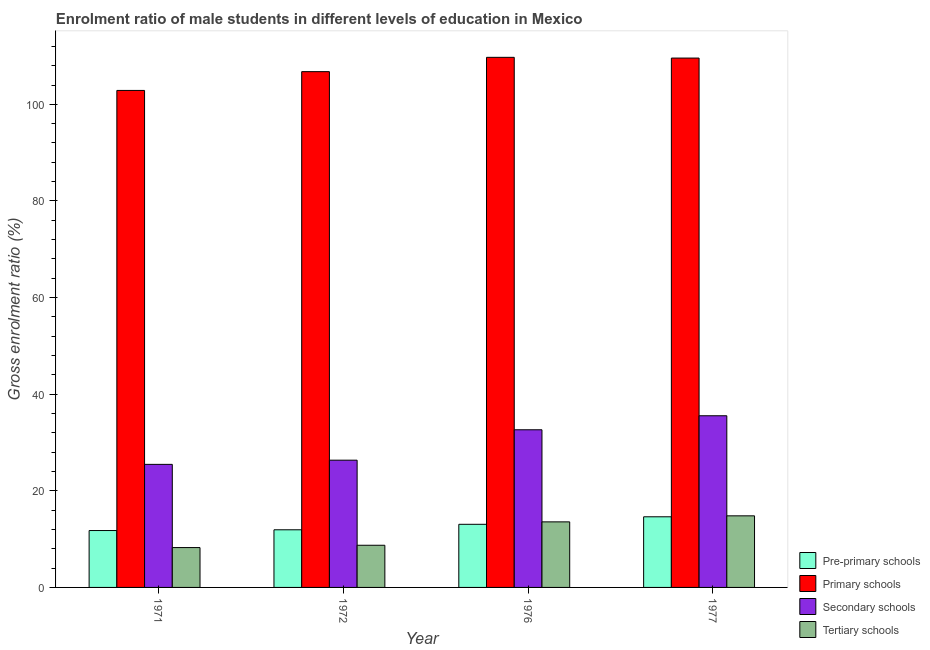Are the number of bars per tick equal to the number of legend labels?
Give a very brief answer. Yes. Are the number of bars on each tick of the X-axis equal?
Your answer should be compact. Yes. How many bars are there on the 3rd tick from the right?
Offer a terse response. 4. What is the label of the 2nd group of bars from the left?
Offer a terse response. 1972. In how many cases, is the number of bars for a given year not equal to the number of legend labels?
Your answer should be very brief. 0. What is the gross enrolment ratio(female) in secondary schools in 1977?
Give a very brief answer. 35.54. Across all years, what is the maximum gross enrolment ratio(female) in primary schools?
Your answer should be compact. 109.73. Across all years, what is the minimum gross enrolment ratio(female) in pre-primary schools?
Make the answer very short. 11.78. In which year was the gross enrolment ratio(female) in primary schools maximum?
Your response must be concise. 1976. What is the total gross enrolment ratio(female) in primary schools in the graph?
Your answer should be very brief. 428.96. What is the difference between the gross enrolment ratio(female) in tertiary schools in 1972 and that in 1977?
Keep it short and to the point. -6.09. What is the difference between the gross enrolment ratio(female) in pre-primary schools in 1971 and the gross enrolment ratio(female) in tertiary schools in 1976?
Give a very brief answer. -1.29. What is the average gross enrolment ratio(female) in secondary schools per year?
Offer a very short reply. 30. What is the ratio of the gross enrolment ratio(female) in primary schools in 1971 to that in 1972?
Provide a short and direct response. 0.96. What is the difference between the highest and the second highest gross enrolment ratio(female) in pre-primary schools?
Keep it short and to the point. 1.56. What is the difference between the highest and the lowest gross enrolment ratio(female) in secondary schools?
Keep it short and to the point. 10.06. What does the 1st bar from the left in 1977 represents?
Make the answer very short. Pre-primary schools. What does the 2nd bar from the right in 1971 represents?
Make the answer very short. Secondary schools. Is it the case that in every year, the sum of the gross enrolment ratio(female) in pre-primary schools and gross enrolment ratio(female) in primary schools is greater than the gross enrolment ratio(female) in secondary schools?
Your response must be concise. Yes. What is the difference between two consecutive major ticks on the Y-axis?
Your answer should be compact. 20. Does the graph contain grids?
Make the answer very short. No. How many legend labels are there?
Provide a short and direct response. 4. How are the legend labels stacked?
Offer a terse response. Vertical. What is the title of the graph?
Give a very brief answer. Enrolment ratio of male students in different levels of education in Mexico. Does "Secondary vocational education" appear as one of the legend labels in the graph?
Give a very brief answer. No. What is the label or title of the Y-axis?
Make the answer very short. Gross enrolment ratio (%). What is the Gross enrolment ratio (%) of Pre-primary schools in 1971?
Keep it short and to the point. 11.78. What is the Gross enrolment ratio (%) of Primary schools in 1971?
Ensure brevity in your answer.  102.88. What is the Gross enrolment ratio (%) in Secondary schools in 1971?
Your answer should be compact. 25.47. What is the Gross enrolment ratio (%) in Tertiary schools in 1971?
Your response must be concise. 8.25. What is the Gross enrolment ratio (%) in Pre-primary schools in 1972?
Provide a succinct answer. 11.93. What is the Gross enrolment ratio (%) in Primary schools in 1972?
Your answer should be compact. 106.77. What is the Gross enrolment ratio (%) in Secondary schools in 1972?
Your response must be concise. 26.34. What is the Gross enrolment ratio (%) of Tertiary schools in 1972?
Your answer should be very brief. 8.73. What is the Gross enrolment ratio (%) of Pre-primary schools in 1976?
Your answer should be compact. 13.06. What is the Gross enrolment ratio (%) of Primary schools in 1976?
Ensure brevity in your answer.  109.73. What is the Gross enrolment ratio (%) of Secondary schools in 1976?
Offer a very short reply. 32.63. What is the Gross enrolment ratio (%) in Tertiary schools in 1976?
Keep it short and to the point. 13.57. What is the Gross enrolment ratio (%) in Pre-primary schools in 1977?
Keep it short and to the point. 14.62. What is the Gross enrolment ratio (%) of Primary schools in 1977?
Offer a terse response. 109.58. What is the Gross enrolment ratio (%) in Secondary schools in 1977?
Provide a short and direct response. 35.54. What is the Gross enrolment ratio (%) of Tertiary schools in 1977?
Give a very brief answer. 14.82. Across all years, what is the maximum Gross enrolment ratio (%) in Pre-primary schools?
Ensure brevity in your answer.  14.62. Across all years, what is the maximum Gross enrolment ratio (%) of Primary schools?
Make the answer very short. 109.73. Across all years, what is the maximum Gross enrolment ratio (%) of Secondary schools?
Provide a short and direct response. 35.54. Across all years, what is the maximum Gross enrolment ratio (%) in Tertiary schools?
Your answer should be very brief. 14.82. Across all years, what is the minimum Gross enrolment ratio (%) of Pre-primary schools?
Provide a succinct answer. 11.78. Across all years, what is the minimum Gross enrolment ratio (%) in Primary schools?
Provide a succinct answer. 102.88. Across all years, what is the minimum Gross enrolment ratio (%) in Secondary schools?
Ensure brevity in your answer.  25.47. Across all years, what is the minimum Gross enrolment ratio (%) in Tertiary schools?
Provide a short and direct response. 8.25. What is the total Gross enrolment ratio (%) in Pre-primary schools in the graph?
Offer a terse response. 51.39. What is the total Gross enrolment ratio (%) of Primary schools in the graph?
Your response must be concise. 428.96. What is the total Gross enrolment ratio (%) in Secondary schools in the graph?
Offer a terse response. 119.99. What is the total Gross enrolment ratio (%) in Tertiary schools in the graph?
Offer a terse response. 45.37. What is the difference between the Gross enrolment ratio (%) of Pre-primary schools in 1971 and that in 1972?
Offer a very short reply. -0.15. What is the difference between the Gross enrolment ratio (%) in Primary schools in 1971 and that in 1972?
Make the answer very short. -3.89. What is the difference between the Gross enrolment ratio (%) in Secondary schools in 1971 and that in 1972?
Make the answer very short. -0.87. What is the difference between the Gross enrolment ratio (%) in Tertiary schools in 1971 and that in 1972?
Provide a succinct answer. -0.48. What is the difference between the Gross enrolment ratio (%) in Pre-primary schools in 1971 and that in 1976?
Provide a succinct answer. -1.29. What is the difference between the Gross enrolment ratio (%) of Primary schools in 1971 and that in 1976?
Provide a succinct answer. -6.85. What is the difference between the Gross enrolment ratio (%) of Secondary schools in 1971 and that in 1976?
Ensure brevity in your answer.  -7.16. What is the difference between the Gross enrolment ratio (%) of Tertiary schools in 1971 and that in 1976?
Offer a very short reply. -5.32. What is the difference between the Gross enrolment ratio (%) of Pre-primary schools in 1971 and that in 1977?
Offer a terse response. -2.84. What is the difference between the Gross enrolment ratio (%) in Primary schools in 1971 and that in 1977?
Offer a very short reply. -6.7. What is the difference between the Gross enrolment ratio (%) in Secondary schools in 1971 and that in 1977?
Make the answer very short. -10.06. What is the difference between the Gross enrolment ratio (%) of Tertiary schools in 1971 and that in 1977?
Your answer should be very brief. -6.57. What is the difference between the Gross enrolment ratio (%) in Pre-primary schools in 1972 and that in 1976?
Your response must be concise. -1.13. What is the difference between the Gross enrolment ratio (%) of Primary schools in 1972 and that in 1976?
Your answer should be compact. -2.96. What is the difference between the Gross enrolment ratio (%) in Secondary schools in 1972 and that in 1976?
Your answer should be compact. -6.29. What is the difference between the Gross enrolment ratio (%) of Tertiary schools in 1972 and that in 1976?
Make the answer very short. -4.84. What is the difference between the Gross enrolment ratio (%) in Pre-primary schools in 1972 and that in 1977?
Give a very brief answer. -2.69. What is the difference between the Gross enrolment ratio (%) of Primary schools in 1972 and that in 1977?
Provide a short and direct response. -2.81. What is the difference between the Gross enrolment ratio (%) of Secondary schools in 1972 and that in 1977?
Offer a terse response. -9.2. What is the difference between the Gross enrolment ratio (%) of Tertiary schools in 1972 and that in 1977?
Keep it short and to the point. -6.09. What is the difference between the Gross enrolment ratio (%) of Pre-primary schools in 1976 and that in 1977?
Provide a short and direct response. -1.56. What is the difference between the Gross enrolment ratio (%) of Primary schools in 1976 and that in 1977?
Your answer should be compact. 0.15. What is the difference between the Gross enrolment ratio (%) in Secondary schools in 1976 and that in 1977?
Provide a succinct answer. -2.9. What is the difference between the Gross enrolment ratio (%) of Tertiary schools in 1976 and that in 1977?
Offer a terse response. -1.25. What is the difference between the Gross enrolment ratio (%) in Pre-primary schools in 1971 and the Gross enrolment ratio (%) in Primary schools in 1972?
Provide a succinct answer. -94.99. What is the difference between the Gross enrolment ratio (%) of Pre-primary schools in 1971 and the Gross enrolment ratio (%) of Secondary schools in 1972?
Give a very brief answer. -14.56. What is the difference between the Gross enrolment ratio (%) in Pre-primary schools in 1971 and the Gross enrolment ratio (%) in Tertiary schools in 1972?
Your answer should be very brief. 3.05. What is the difference between the Gross enrolment ratio (%) in Primary schools in 1971 and the Gross enrolment ratio (%) in Secondary schools in 1972?
Your response must be concise. 76.54. What is the difference between the Gross enrolment ratio (%) in Primary schools in 1971 and the Gross enrolment ratio (%) in Tertiary schools in 1972?
Keep it short and to the point. 94.15. What is the difference between the Gross enrolment ratio (%) of Secondary schools in 1971 and the Gross enrolment ratio (%) of Tertiary schools in 1972?
Offer a terse response. 16.75. What is the difference between the Gross enrolment ratio (%) in Pre-primary schools in 1971 and the Gross enrolment ratio (%) in Primary schools in 1976?
Your response must be concise. -97.96. What is the difference between the Gross enrolment ratio (%) in Pre-primary schools in 1971 and the Gross enrolment ratio (%) in Secondary schools in 1976?
Keep it short and to the point. -20.86. What is the difference between the Gross enrolment ratio (%) in Pre-primary schools in 1971 and the Gross enrolment ratio (%) in Tertiary schools in 1976?
Provide a succinct answer. -1.79. What is the difference between the Gross enrolment ratio (%) of Primary schools in 1971 and the Gross enrolment ratio (%) of Secondary schools in 1976?
Ensure brevity in your answer.  70.25. What is the difference between the Gross enrolment ratio (%) of Primary schools in 1971 and the Gross enrolment ratio (%) of Tertiary schools in 1976?
Make the answer very short. 89.31. What is the difference between the Gross enrolment ratio (%) in Secondary schools in 1971 and the Gross enrolment ratio (%) in Tertiary schools in 1976?
Make the answer very short. 11.9. What is the difference between the Gross enrolment ratio (%) of Pre-primary schools in 1971 and the Gross enrolment ratio (%) of Primary schools in 1977?
Your response must be concise. -97.8. What is the difference between the Gross enrolment ratio (%) of Pre-primary schools in 1971 and the Gross enrolment ratio (%) of Secondary schools in 1977?
Offer a very short reply. -23.76. What is the difference between the Gross enrolment ratio (%) of Pre-primary schools in 1971 and the Gross enrolment ratio (%) of Tertiary schools in 1977?
Your answer should be very brief. -3.04. What is the difference between the Gross enrolment ratio (%) in Primary schools in 1971 and the Gross enrolment ratio (%) in Secondary schools in 1977?
Provide a succinct answer. 67.34. What is the difference between the Gross enrolment ratio (%) of Primary schools in 1971 and the Gross enrolment ratio (%) of Tertiary schools in 1977?
Make the answer very short. 88.06. What is the difference between the Gross enrolment ratio (%) in Secondary schools in 1971 and the Gross enrolment ratio (%) in Tertiary schools in 1977?
Provide a succinct answer. 10.65. What is the difference between the Gross enrolment ratio (%) of Pre-primary schools in 1972 and the Gross enrolment ratio (%) of Primary schools in 1976?
Your answer should be very brief. -97.8. What is the difference between the Gross enrolment ratio (%) in Pre-primary schools in 1972 and the Gross enrolment ratio (%) in Secondary schools in 1976?
Your response must be concise. -20.7. What is the difference between the Gross enrolment ratio (%) of Pre-primary schools in 1972 and the Gross enrolment ratio (%) of Tertiary schools in 1976?
Your response must be concise. -1.64. What is the difference between the Gross enrolment ratio (%) of Primary schools in 1972 and the Gross enrolment ratio (%) of Secondary schools in 1976?
Offer a terse response. 74.13. What is the difference between the Gross enrolment ratio (%) of Primary schools in 1972 and the Gross enrolment ratio (%) of Tertiary schools in 1976?
Your response must be concise. 93.2. What is the difference between the Gross enrolment ratio (%) in Secondary schools in 1972 and the Gross enrolment ratio (%) in Tertiary schools in 1976?
Provide a short and direct response. 12.77. What is the difference between the Gross enrolment ratio (%) in Pre-primary schools in 1972 and the Gross enrolment ratio (%) in Primary schools in 1977?
Your response must be concise. -97.65. What is the difference between the Gross enrolment ratio (%) in Pre-primary schools in 1972 and the Gross enrolment ratio (%) in Secondary schools in 1977?
Ensure brevity in your answer.  -23.61. What is the difference between the Gross enrolment ratio (%) of Pre-primary schools in 1972 and the Gross enrolment ratio (%) of Tertiary schools in 1977?
Offer a very short reply. -2.89. What is the difference between the Gross enrolment ratio (%) in Primary schools in 1972 and the Gross enrolment ratio (%) in Secondary schools in 1977?
Offer a terse response. 71.23. What is the difference between the Gross enrolment ratio (%) in Primary schools in 1972 and the Gross enrolment ratio (%) in Tertiary schools in 1977?
Provide a short and direct response. 91.95. What is the difference between the Gross enrolment ratio (%) of Secondary schools in 1972 and the Gross enrolment ratio (%) of Tertiary schools in 1977?
Offer a very short reply. 11.52. What is the difference between the Gross enrolment ratio (%) in Pre-primary schools in 1976 and the Gross enrolment ratio (%) in Primary schools in 1977?
Your response must be concise. -96.51. What is the difference between the Gross enrolment ratio (%) in Pre-primary schools in 1976 and the Gross enrolment ratio (%) in Secondary schools in 1977?
Give a very brief answer. -22.47. What is the difference between the Gross enrolment ratio (%) in Pre-primary schools in 1976 and the Gross enrolment ratio (%) in Tertiary schools in 1977?
Your answer should be compact. -1.75. What is the difference between the Gross enrolment ratio (%) of Primary schools in 1976 and the Gross enrolment ratio (%) of Secondary schools in 1977?
Offer a very short reply. 74.2. What is the difference between the Gross enrolment ratio (%) in Primary schools in 1976 and the Gross enrolment ratio (%) in Tertiary schools in 1977?
Provide a short and direct response. 94.91. What is the difference between the Gross enrolment ratio (%) in Secondary schools in 1976 and the Gross enrolment ratio (%) in Tertiary schools in 1977?
Provide a succinct answer. 17.82. What is the average Gross enrolment ratio (%) in Pre-primary schools per year?
Offer a terse response. 12.85. What is the average Gross enrolment ratio (%) of Primary schools per year?
Make the answer very short. 107.24. What is the average Gross enrolment ratio (%) in Secondary schools per year?
Keep it short and to the point. 30. What is the average Gross enrolment ratio (%) in Tertiary schools per year?
Your response must be concise. 11.34. In the year 1971, what is the difference between the Gross enrolment ratio (%) in Pre-primary schools and Gross enrolment ratio (%) in Primary schools?
Your answer should be compact. -91.1. In the year 1971, what is the difference between the Gross enrolment ratio (%) of Pre-primary schools and Gross enrolment ratio (%) of Secondary schools?
Make the answer very short. -13.7. In the year 1971, what is the difference between the Gross enrolment ratio (%) of Pre-primary schools and Gross enrolment ratio (%) of Tertiary schools?
Your response must be concise. 3.53. In the year 1971, what is the difference between the Gross enrolment ratio (%) in Primary schools and Gross enrolment ratio (%) in Secondary schools?
Offer a very short reply. 77.41. In the year 1971, what is the difference between the Gross enrolment ratio (%) of Primary schools and Gross enrolment ratio (%) of Tertiary schools?
Ensure brevity in your answer.  94.63. In the year 1971, what is the difference between the Gross enrolment ratio (%) in Secondary schools and Gross enrolment ratio (%) in Tertiary schools?
Your answer should be compact. 17.22. In the year 1972, what is the difference between the Gross enrolment ratio (%) in Pre-primary schools and Gross enrolment ratio (%) in Primary schools?
Your answer should be compact. -94.84. In the year 1972, what is the difference between the Gross enrolment ratio (%) in Pre-primary schools and Gross enrolment ratio (%) in Secondary schools?
Provide a short and direct response. -14.41. In the year 1972, what is the difference between the Gross enrolment ratio (%) of Pre-primary schools and Gross enrolment ratio (%) of Tertiary schools?
Give a very brief answer. 3.2. In the year 1972, what is the difference between the Gross enrolment ratio (%) of Primary schools and Gross enrolment ratio (%) of Secondary schools?
Offer a terse response. 80.43. In the year 1972, what is the difference between the Gross enrolment ratio (%) of Primary schools and Gross enrolment ratio (%) of Tertiary schools?
Your answer should be very brief. 98.04. In the year 1972, what is the difference between the Gross enrolment ratio (%) of Secondary schools and Gross enrolment ratio (%) of Tertiary schools?
Your answer should be very brief. 17.61. In the year 1976, what is the difference between the Gross enrolment ratio (%) in Pre-primary schools and Gross enrolment ratio (%) in Primary schools?
Provide a succinct answer. -96.67. In the year 1976, what is the difference between the Gross enrolment ratio (%) of Pre-primary schools and Gross enrolment ratio (%) of Secondary schools?
Keep it short and to the point. -19.57. In the year 1976, what is the difference between the Gross enrolment ratio (%) of Pre-primary schools and Gross enrolment ratio (%) of Tertiary schools?
Your response must be concise. -0.51. In the year 1976, what is the difference between the Gross enrolment ratio (%) in Primary schools and Gross enrolment ratio (%) in Secondary schools?
Offer a terse response. 77.1. In the year 1976, what is the difference between the Gross enrolment ratio (%) in Primary schools and Gross enrolment ratio (%) in Tertiary schools?
Provide a short and direct response. 96.16. In the year 1976, what is the difference between the Gross enrolment ratio (%) of Secondary schools and Gross enrolment ratio (%) of Tertiary schools?
Ensure brevity in your answer.  19.06. In the year 1977, what is the difference between the Gross enrolment ratio (%) of Pre-primary schools and Gross enrolment ratio (%) of Primary schools?
Keep it short and to the point. -94.96. In the year 1977, what is the difference between the Gross enrolment ratio (%) in Pre-primary schools and Gross enrolment ratio (%) in Secondary schools?
Offer a very short reply. -20.92. In the year 1977, what is the difference between the Gross enrolment ratio (%) in Pre-primary schools and Gross enrolment ratio (%) in Tertiary schools?
Give a very brief answer. -0.2. In the year 1977, what is the difference between the Gross enrolment ratio (%) of Primary schools and Gross enrolment ratio (%) of Secondary schools?
Offer a very short reply. 74.04. In the year 1977, what is the difference between the Gross enrolment ratio (%) of Primary schools and Gross enrolment ratio (%) of Tertiary schools?
Give a very brief answer. 94.76. In the year 1977, what is the difference between the Gross enrolment ratio (%) of Secondary schools and Gross enrolment ratio (%) of Tertiary schools?
Give a very brief answer. 20.72. What is the ratio of the Gross enrolment ratio (%) in Pre-primary schools in 1971 to that in 1972?
Make the answer very short. 0.99. What is the ratio of the Gross enrolment ratio (%) of Primary schools in 1971 to that in 1972?
Make the answer very short. 0.96. What is the ratio of the Gross enrolment ratio (%) of Tertiary schools in 1971 to that in 1972?
Ensure brevity in your answer.  0.95. What is the ratio of the Gross enrolment ratio (%) of Pre-primary schools in 1971 to that in 1976?
Your answer should be compact. 0.9. What is the ratio of the Gross enrolment ratio (%) of Primary schools in 1971 to that in 1976?
Make the answer very short. 0.94. What is the ratio of the Gross enrolment ratio (%) of Secondary schools in 1971 to that in 1976?
Give a very brief answer. 0.78. What is the ratio of the Gross enrolment ratio (%) of Tertiary schools in 1971 to that in 1976?
Your response must be concise. 0.61. What is the ratio of the Gross enrolment ratio (%) of Pre-primary schools in 1971 to that in 1977?
Ensure brevity in your answer.  0.81. What is the ratio of the Gross enrolment ratio (%) in Primary schools in 1971 to that in 1977?
Your answer should be compact. 0.94. What is the ratio of the Gross enrolment ratio (%) of Secondary schools in 1971 to that in 1977?
Keep it short and to the point. 0.72. What is the ratio of the Gross enrolment ratio (%) in Tertiary schools in 1971 to that in 1977?
Your answer should be compact. 0.56. What is the ratio of the Gross enrolment ratio (%) in Pre-primary schools in 1972 to that in 1976?
Offer a very short reply. 0.91. What is the ratio of the Gross enrolment ratio (%) in Secondary schools in 1972 to that in 1976?
Your answer should be compact. 0.81. What is the ratio of the Gross enrolment ratio (%) in Tertiary schools in 1972 to that in 1976?
Keep it short and to the point. 0.64. What is the ratio of the Gross enrolment ratio (%) of Pre-primary schools in 1972 to that in 1977?
Your answer should be very brief. 0.82. What is the ratio of the Gross enrolment ratio (%) in Primary schools in 1972 to that in 1977?
Give a very brief answer. 0.97. What is the ratio of the Gross enrolment ratio (%) in Secondary schools in 1972 to that in 1977?
Your response must be concise. 0.74. What is the ratio of the Gross enrolment ratio (%) in Tertiary schools in 1972 to that in 1977?
Your answer should be very brief. 0.59. What is the ratio of the Gross enrolment ratio (%) of Pre-primary schools in 1976 to that in 1977?
Keep it short and to the point. 0.89. What is the ratio of the Gross enrolment ratio (%) in Primary schools in 1976 to that in 1977?
Make the answer very short. 1. What is the ratio of the Gross enrolment ratio (%) of Secondary schools in 1976 to that in 1977?
Make the answer very short. 0.92. What is the ratio of the Gross enrolment ratio (%) of Tertiary schools in 1976 to that in 1977?
Offer a very short reply. 0.92. What is the difference between the highest and the second highest Gross enrolment ratio (%) of Pre-primary schools?
Give a very brief answer. 1.56. What is the difference between the highest and the second highest Gross enrolment ratio (%) in Primary schools?
Offer a very short reply. 0.15. What is the difference between the highest and the second highest Gross enrolment ratio (%) of Secondary schools?
Ensure brevity in your answer.  2.9. What is the difference between the highest and the second highest Gross enrolment ratio (%) in Tertiary schools?
Ensure brevity in your answer.  1.25. What is the difference between the highest and the lowest Gross enrolment ratio (%) of Pre-primary schools?
Offer a very short reply. 2.84. What is the difference between the highest and the lowest Gross enrolment ratio (%) in Primary schools?
Provide a succinct answer. 6.85. What is the difference between the highest and the lowest Gross enrolment ratio (%) of Secondary schools?
Keep it short and to the point. 10.06. What is the difference between the highest and the lowest Gross enrolment ratio (%) of Tertiary schools?
Make the answer very short. 6.57. 